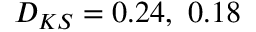<formula> <loc_0><loc_0><loc_500><loc_500>D _ { K S } = 0 . 2 4 , \ 0 . 1 8</formula> 